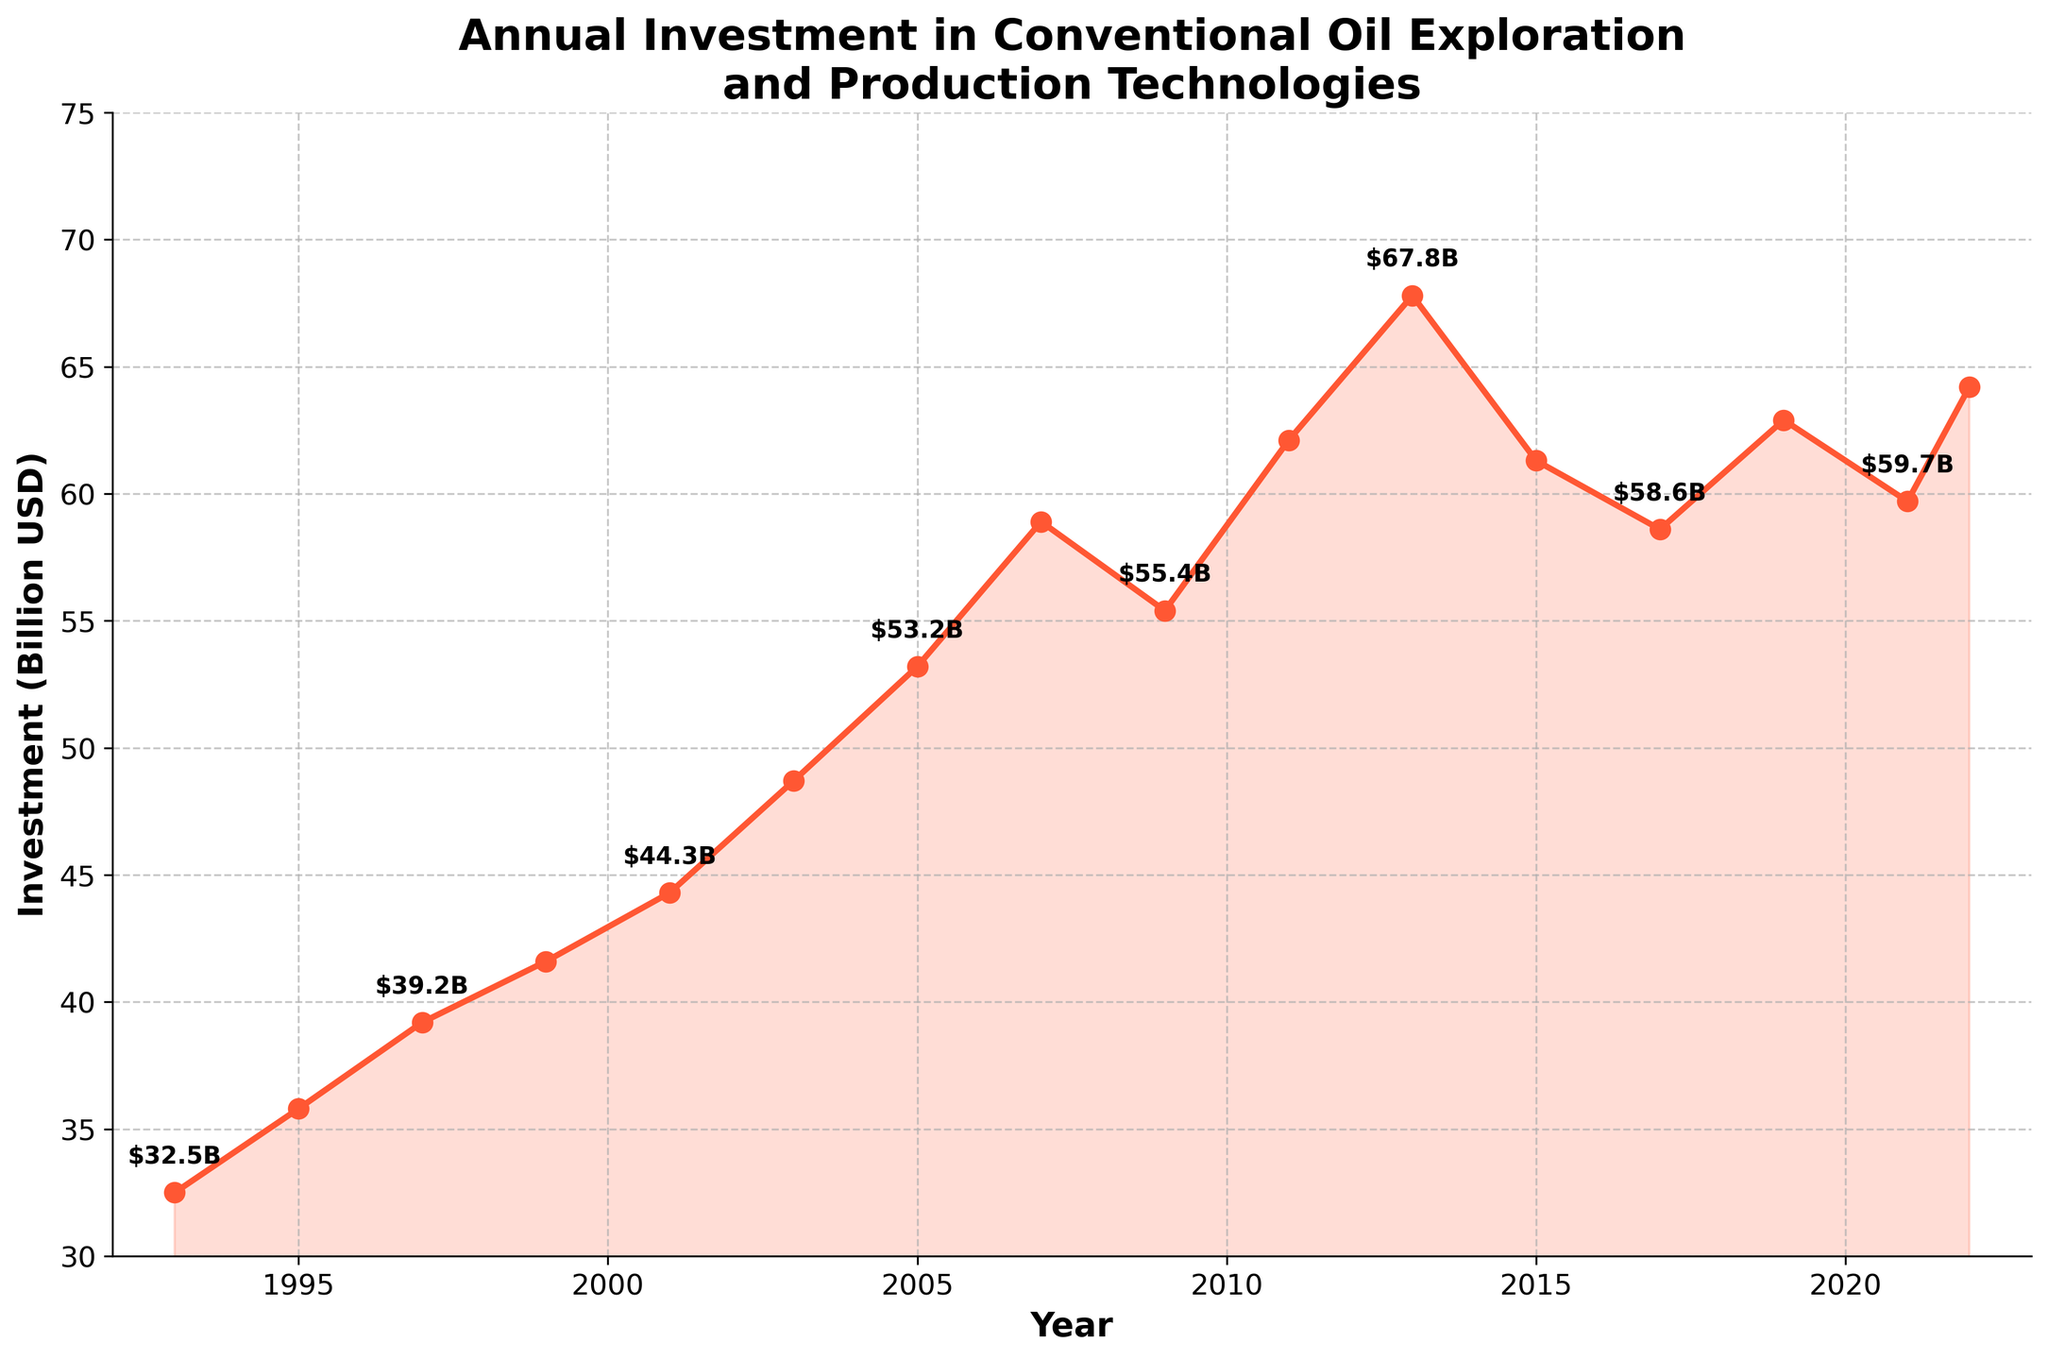What was the investment in conventional oil exploration and production technologies in the year 1999? The data indicates the investments for various years. For 1999, look at the data point corresponding to that year.
Answer: 41.6 Billion USD During which year did the investment peak according to the chart? The peak investment can be identified by locating the highest point on the line chart.
Answer: 2013 Which year had a lower investment, 2009 or 2021? Compare the investment values for both years: 2009 and 2021. The chart shows 55.4 for 2009 and 59.7 for 2021.
Answer: 2009 What is the average investment from 1993 to 2022? Sum all investment values from 1993 to 2022 and divide by the number of years. Total investment: 32.5 + 35.8 + 39.2 + 41.6 + 44.3 + 48.7 + 53.2 + 58.9 + 55.4 + 62.1 + 67.8 + 61.3 + 58.6 + 62.9 + 59.7 + 64.2 = 845.2. Divided by 16 years gives: 845.2 / 16 = 52.825.
Answer: 52.825 Billion USD How did the investment in 2011 compare to that in 2017? Look at the data points for both 2011 and 2017. The investment in 2011 is 62.1, and in 2017 it is 58.6.
Answer: 2011 had a higher investment What is the total increase in investment from 1993 to 2022? Subtract the investment value in 1993 from the value in 2022. The value in 1993 is 32.5 and in 2022 is 64.2. Total increase = 64.2 - 32.5 = 31.7.
Answer: 31.7 Billion USD Which year had an investment value closest to 60 Billion USD? Compare investment values for all years and find the one closest to 60 Billion USD. The closest value is 59.7 in the year 2021.
Answer: 2021 Between 2013 and 2015, did the investment increase or decrease and by how much? Subtract the investment value in 2015 from that of 2013. Value in 2013 is 67.8, and in 2015 is 61.3. The change is 67.8 - 61.3 = -6.5, indicating a decrease.
Answer: Decrease by 6.5 Billion USD What's the average investment from the start of the 2000s (2001) to the end of the 2010s (2019)? Sum investment values from 2001 to 2019 and divide by the number of years. Total investment for this period: 44.3 + 48.7 + 53.2 + 58.9 + 55.4 + 62.1 + 67.8 + 61.3 + 58.6 + 62.9 = 573.2. Divided by 10 years: 573.2 / 10 = 57.32.
Answer: 57.32 Billion USD 